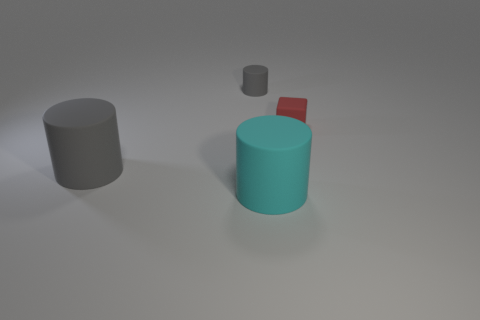Subtract 1 cylinders. How many cylinders are left? 2 Add 2 tiny green shiny blocks. How many objects exist? 6 Add 1 tiny red blocks. How many tiny red blocks exist? 2 Subtract 0 red balls. How many objects are left? 4 Subtract all cylinders. How many objects are left? 1 Subtract all small gray cylinders. Subtract all tiny gray cylinders. How many objects are left? 2 Add 3 big gray rubber cylinders. How many big gray rubber cylinders are left? 4 